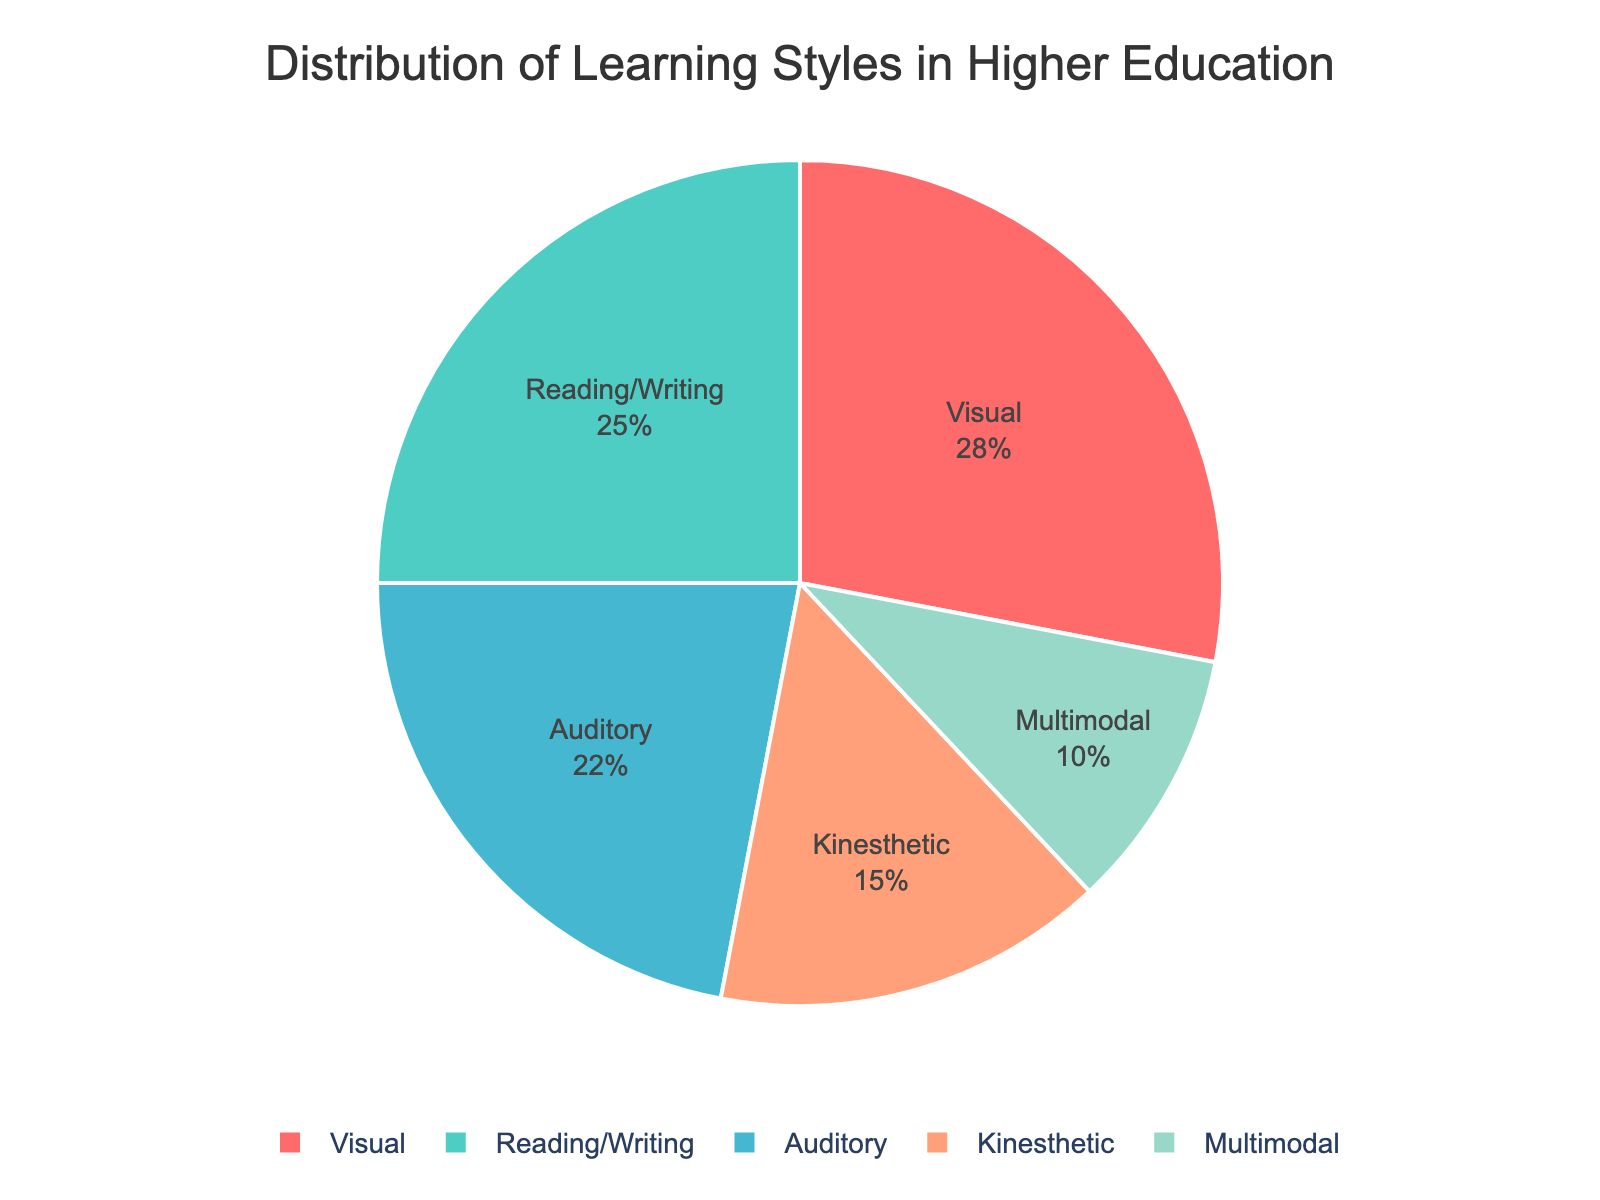What is the most common learning style among students in higher education? The pie chart shows the percentage of different learning styles among students. By observing the chart, we see that the 'Visual' learning style has the largest segment, indicating it is the most common.
Answer: Visual What percentage of students prefer auditory learning? To find this information, we refer to the pie chart segment labeled 'Auditory'. The label shows that 22% of students prefer auditory learning.
Answer: 22% Which learning style has a lower percentage than reading/writing but higher than multimodal? By comparing the segments labeled with percentages, 'Kinesthetic' falls between 'Reading/Writing' (25%) and 'Multimodal' (10%) with a percentage of 15%.
Answer: Kinesthetic What is the combined percentage of students who prefer visual and reading/writing learning styles? To find the combined percentage, add the percentages of 'Visual' (28%) and 'Reading/Writing' (25%): 28% + 25% = 53%.
Answer: 53% How much larger is the percentage of visual learners compared to kinesthetic learners? Subtract the percentage of 'Kinesthetic' learners (15%) from 'Visual' learners (28%): 28% - 15% = 13%.
Answer: 13% Which color represents the multimodal learning style in the pie chart? The legend associated with the pie chart can help here. By identifying the color associated with 'Multimodal' in the legend, we see that it is represented by a greenish shade.
Answer: Greenish What is the sum percentage of students who prefer kinesthetic and auditory learning styles? Adding the percentages for 'Kinesthetic' (15%) and 'Auditory' (22%): 15% + 22% = 37%.
Answer: 37% If the total number of students surveyed is 1000, how many prefer the reading/writing learning style? To find the number of students, multiply the total number of students (1000) by the percentage of 'Reading/Writing' learners (25%): 1000 * 0.25 = 250.
Answer: 250 Are there more students with a multimodal learning style or a kinesthetic learning style? By comparing the pie chart percentages for 'Multimodal' (10%) and 'Kinesthetic' (15%), the 'Kinesthetic' segment is larger. Hence, there are more kinesthetic learners.
Answer: Kinesthetic What is the least common learning style among students? Identify the segment with the smallest percentage in the pie chart. 'Multimodal' has the smallest segment representing 10%.
Answer: Multimodal 